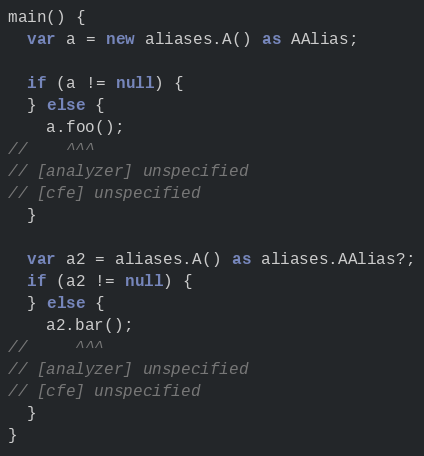Convert code to text. <code><loc_0><loc_0><loc_500><loc_500><_Dart_>main() {
  var a = new aliases.A() as AAlias;

  if (a != null) {
  } else {
    a.foo();
//    ^^^
// [analyzer] unspecified
// [cfe] unspecified
  }

  var a2 = aliases.A() as aliases.AAlias?;
  if (a2 != null) {
  } else {
    a2.bar();
//     ^^^
// [analyzer] unspecified
// [cfe] unspecified
  }
}
</code> 